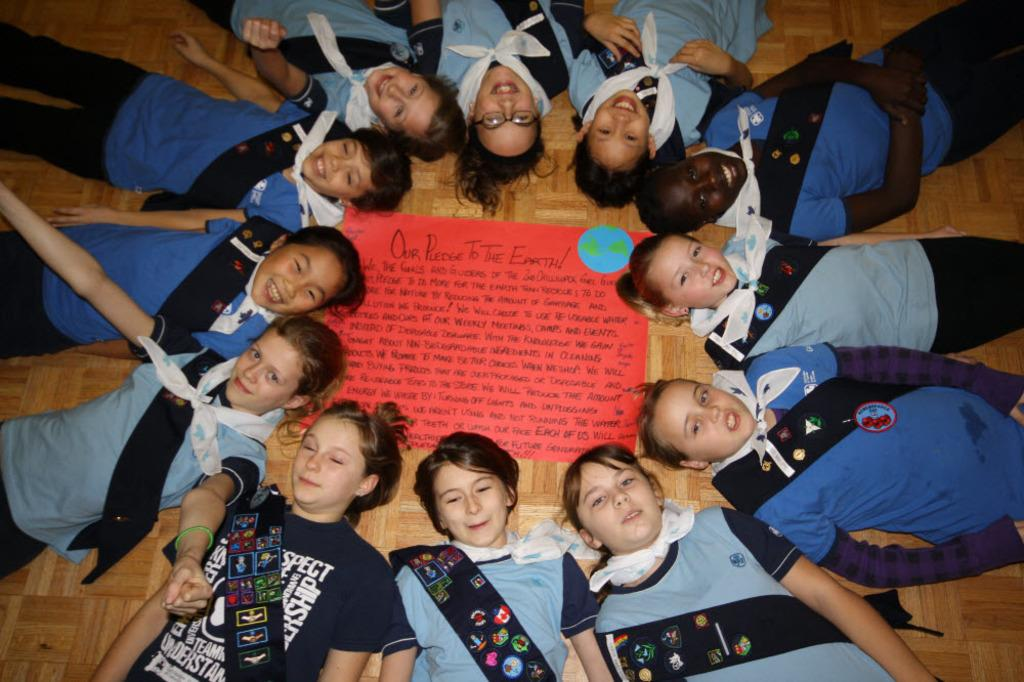What is happening in the image involving a group of people? In the image, there is a group of people lying on the surface with a cloth around their necks. What are some of the people doing with their heads? Some people are holding their heads on a chart. What can be found on the chart? There is text written on the chart. What color is the silver chalk used by the people in the image? There is no silver chalk present in the image, and the people are not using chalk. 